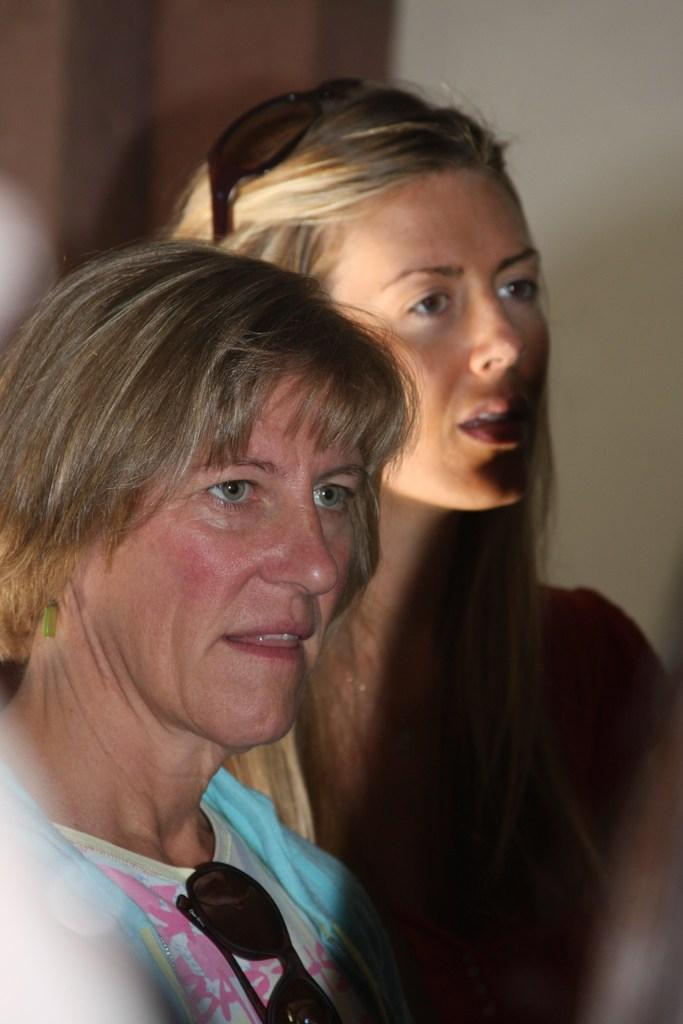Who are the main subjects in the image? There are ladies in the center of the image. What can be seen in the background of the image? There is a wall in the background of the image. How many clocks are hanging on the wall in the image? There are no clocks visible in the image; only the ladies and the wall are present. What type of fuel is being used by the ladies in the image? There is no indication of any fuel being used by the ladies in the image. 